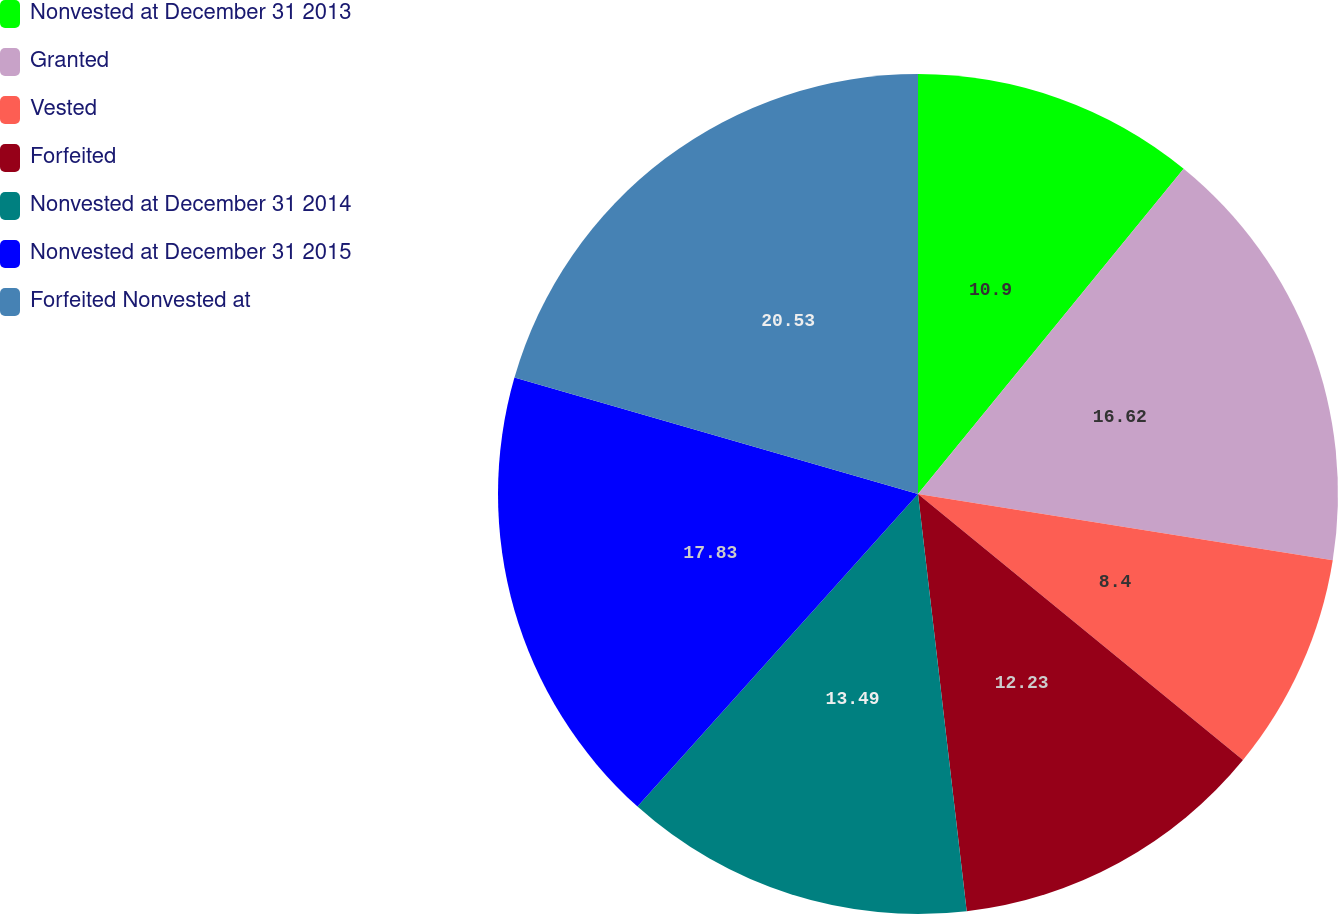<chart> <loc_0><loc_0><loc_500><loc_500><pie_chart><fcel>Nonvested at December 31 2013<fcel>Granted<fcel>Vested<fcel>Forfeited<fcel>Nonvested at December 31 2014<fcel>Nonvested at December 31 2015<fcel>Forfeited Nonvested at<nl><fcel>10.9%<fcel>16.62%<fcel>8.4%<fcel>12.23%<fcel>13.49%<fcel>17.83%<fcel>20.53%<nl></chart> 